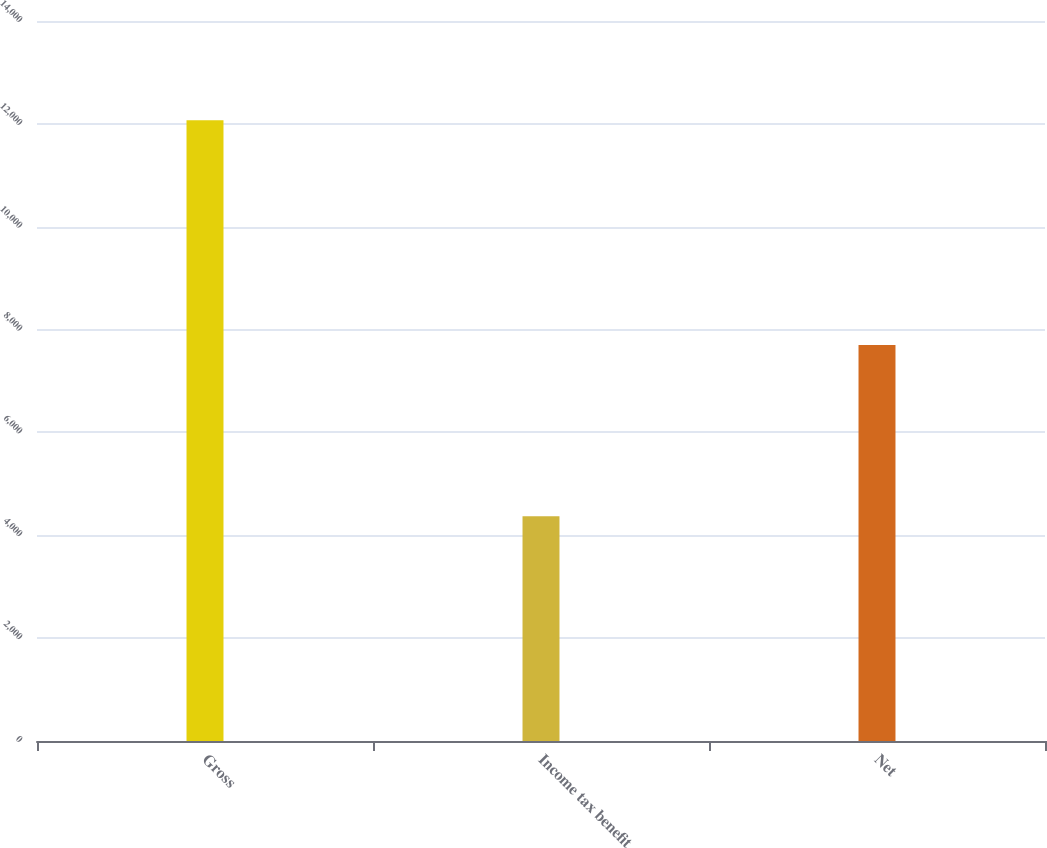<chart> <loc_0><loc_0><loc_500><loc_500><bar_chart><fcel>Gross<fcel>Income tax benefit<fcel>Net<nl><fcel>12069<fcel>4370<fcel>7699<nl></chart> 